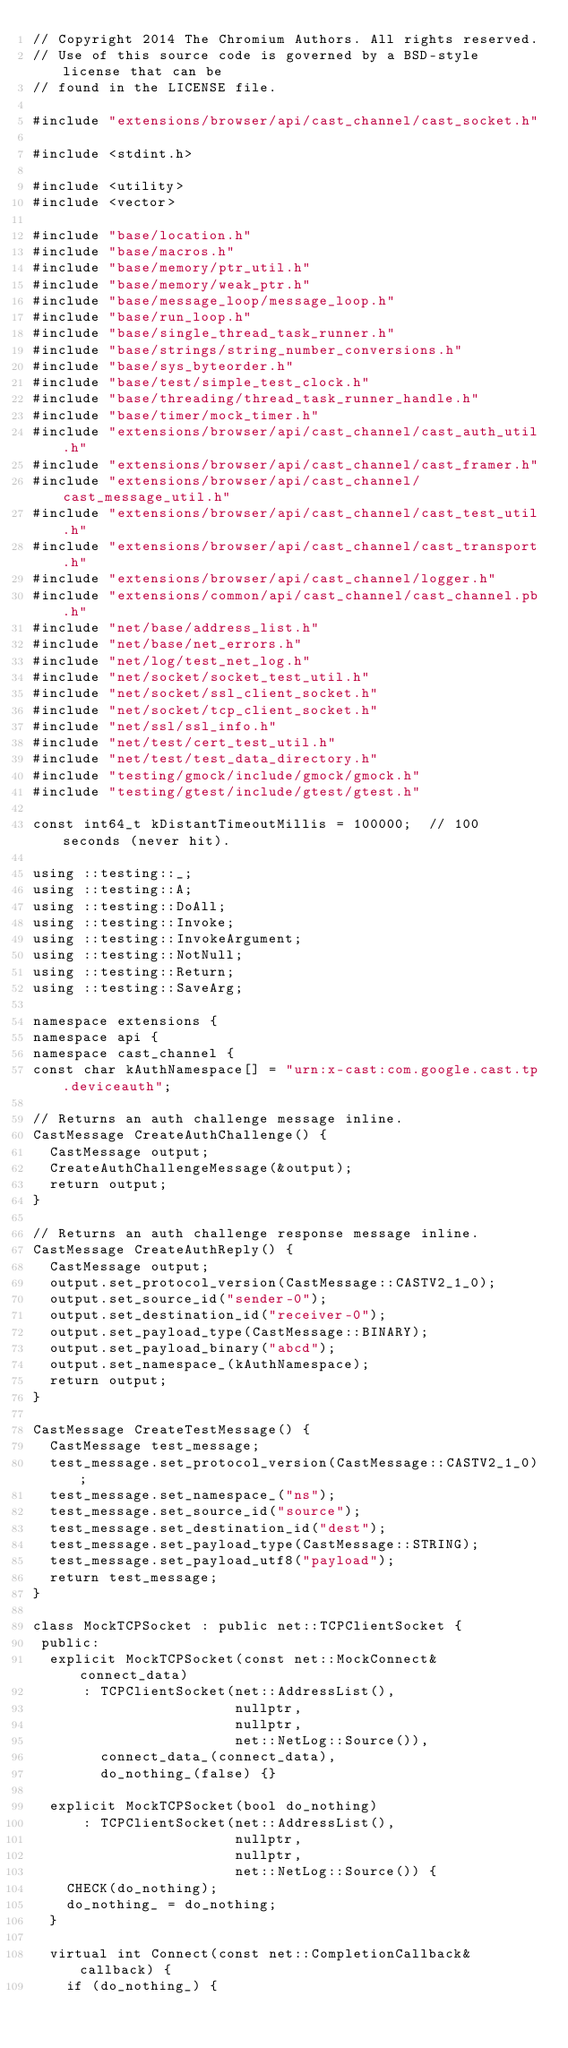Convert code to text. <code><loc_0><loc_0><loc_500><loc_500><_C++_>// Copyright 2014 The Chromium Authors. All rights reserved.
// Use of this source code is governed by a BSD-style license that can be
// found in the LICENSE file.

#include "extensions/browser/api/cast_channel/cast_socket.h"

#include <stdint.h>

#include <utility>
#include <vector>

#include "base/location.h"
#include "base/macros.h"
#include "base/memory/ptr_util.h"
#include "base/memory/weak_ptr.h"
#include "base/message_loop/message_loop.h"
#include "base/run_loop.h"
#include "base/single_thread_task_runner.h"
#include "base/strings/string_number_conversions.h"
#include "base/sys_byteorder.h"
#include "base/test/simple_test_clock.h"
#include "base/threading/thread_task_runner_handle.h"
#include "base/timer/mock_timer.h"
#include "extensions/browser/api/cast_channel/cast_auth_util.h"
#include "extensions/browser/api/cast_channel/cast_framer.h"
#include "extensions/browser/api/cast_channel/cast_message_util.h"
#include "extensions/browser/api/cast_channel/cast_test_util.h"
#include "extensions/browser/api/cast_channel/cast_transport.h"
#include "extensions/browser/api/cast_channel/logger.h"
#include "extensions/common/api/cast_channel/cast_channel.pb.h"
#include "net/base/address_list.h"
#include "net/base/net_errors.h"
#include "net/log/test_net_log.h"
#include "net/socket/socket_test_util.h"
#include "net/socket/ssl_client_socket.h"
#include "net/socket/tcp_client_socket.h"
#include "net/ssl/ssl_info.h"
#include "net/test/cert_test_util.h"
#include "net/test/test_data_directory.h"
#include "testing/gmock/include/gmock/gmock.h"
#include "testing/gtest/include/gtest/gtest.h"

const int64_t kDistantTimeoutMillis = 100000;  // 100 seconds (never hit).

using ::testing::_;
using ::testing::A;
using ::testing::DoAll;
using ::testing::Invoke;
using ::testing::InvokeArgument;
using ::testing::NotNull;
using ::testing::Return;
using ::testing::SaveArg;

namespace extensions {
namespace api {
namespace cast_channel {
const char kAuthNamespace[] = "urn:x-cast:com.google.cast.tp.deviceauth";

// Returns an auth challenge message inline.
CastMessage CreateAuthChallenge() {
  CastMessage output;
  CreateAuthChallengeMessage(&output);
  return output;
}

// Returns an auth challenge response message inline.
CastMessage CreateAuthReply() {
  CastMessage output;
  output.set_protocol_version(CastMessage::CASTV2_1_0);
  output.set_source_id("sender-0");
  output.set_destination_id("receiver-0");
  output.set_payload_type(CastMessage::BINARY);
  output.set_payload_binary("abcd");
  output.set_namespace_(kAuthNamespace);
  return output;
}

CastMessage CreateTestMessage() {
  CastMessage test_message;
  test_message.set_protocol_version(CastMessage::CASTV2_1_0);
  test_message.set_namespace_("ns");
  test_message.set_source_id("source");
  test_message.set_destination_id("dest");
  test_message.set_payload_type(CastMessage::STRING);
  test_message.set_payload_utf8("payload");
  return test_message;
}

class MockTCPSocket : public net::TCPClientSocket {
 public:
  explicit MockTCPSocket(const net::MockConnect& connect_data)
      : TCPClientSocket(net::AddressList(),
                        nullptr,
                        nullptr,
                        net::NetLog::Source()),
        connect_data_(connect_data),
        do_nothing_(false) {}

  explicit MockTCPSocket(bool do_nothing)
      : TCPClientSocket(net::AddressList(),
                        nullptr,
                        nullptr,
                        net::NetLog::Source()) {
    CHECK(do_nothing);
    do_nothing_ = do_nothing;
  }

  virtual int Connect(const net::CompletionCallback& callback) {
    if (do_nothing_) {</code> 